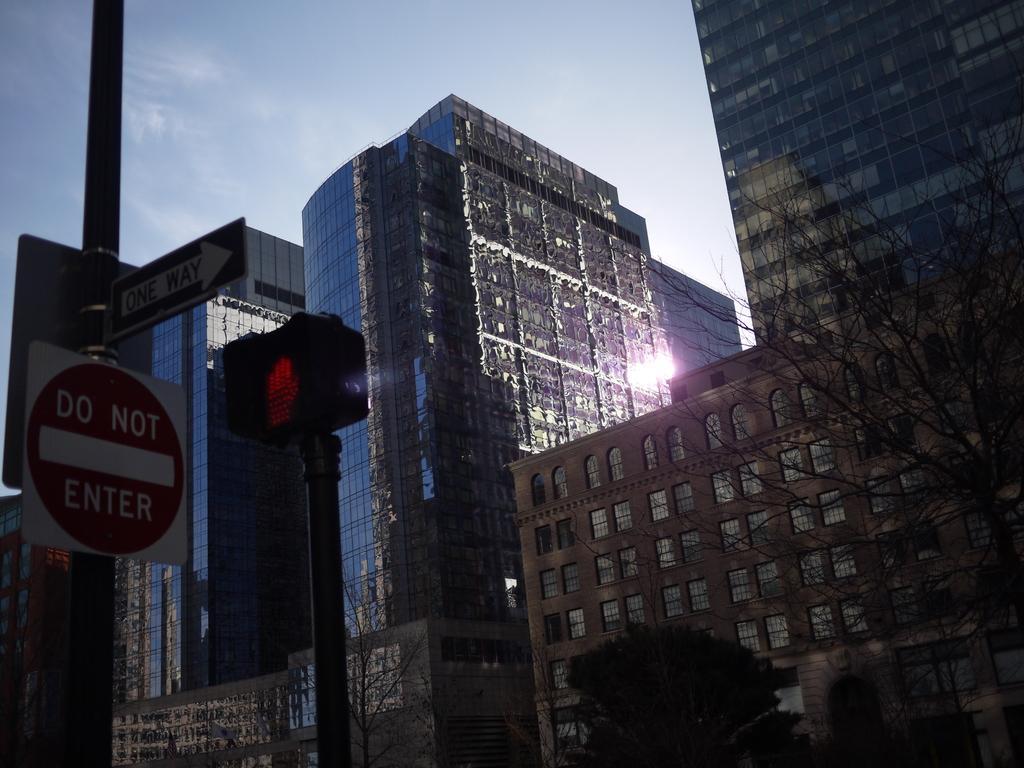Could you give a brief overview of what you see in this image? In the picture I can see buildings, sign boards, traffic light, trees and some other objects. In the background I can see the sky. 